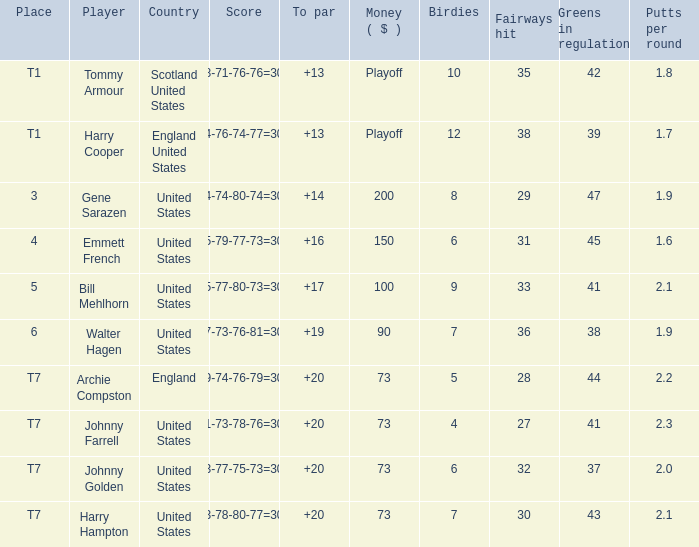Which country has a to par less than 19 and a score of 75-79-77-73=304? United States. 